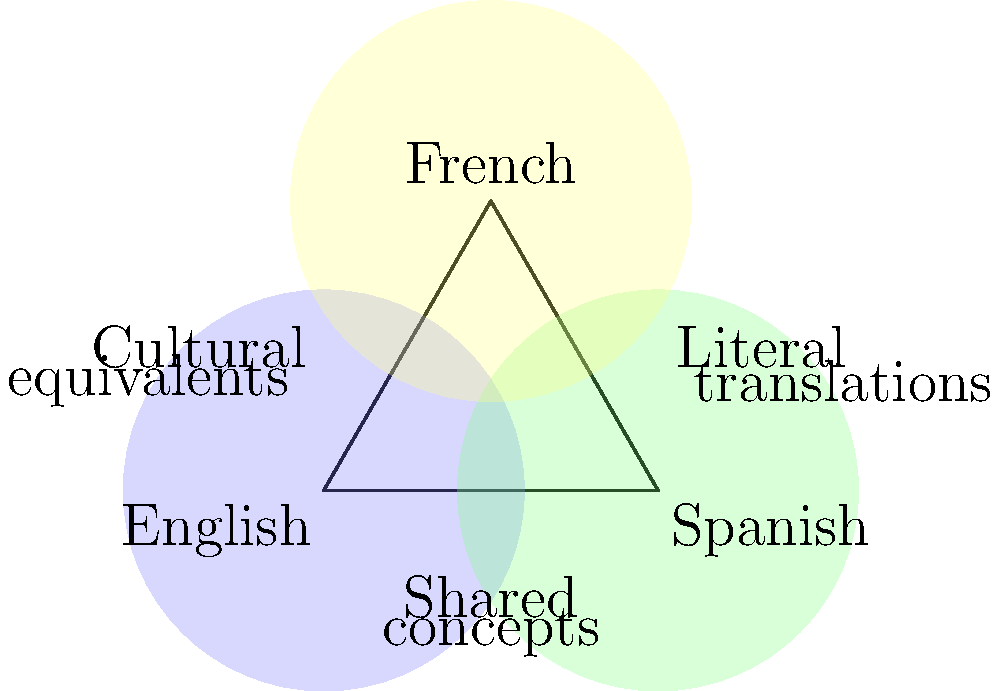In the Venn diagram, three overlapping circles represent the translation of idioms between English, Spanish, and French. The overlapping areas indicate shared concepts or similar expressions. Based on this diagram, which area would best represent idioms that have cultural equivalents in all three languages but may not be literal translations? To answer this question, let's analyze the Venn diagram step by step:

1. The diagram shows three overlapping circles, each representing a language: English, Spanish, and French.

2. The overlapping areas between circles represent shared concepts or similar expressions between languages.

3. The area where all three circles overlap is at the center of the diagram. This represents concepts or idioms that are common to all three languages.

4. The label "Cultural equivalents" is placed on the left side of the diagram, suggesting that idioms with cultural equivalents may not always be literal translations.

5. The label "Literal translations" is placed on the right side, indicating that some idioms may have direct word-for-word translations between languages.

6. The central overlapping area represents idioms that have equivalents in all three languages but may not necessarily be literal translations.

7. This central area best fits the description of idioms with cultural equivalents in all three languages that may not be literal translations.

Therefore, the area where all three circles overlap (the center of the Venn diagram) is the best representation for idioms that have cultural equivalents in all three languages but may not be literal translations.
Answer: The central overlapping area of all three circles 